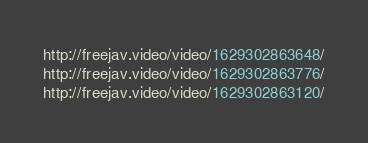<code> <loc_0><loc_0><loc_500><loc_500><_SQL_>http://freejav.video/video/1629302863648/
http://freejav.video/video/1629302863776/
http://freejav.video/video/1629302863120/</code> 